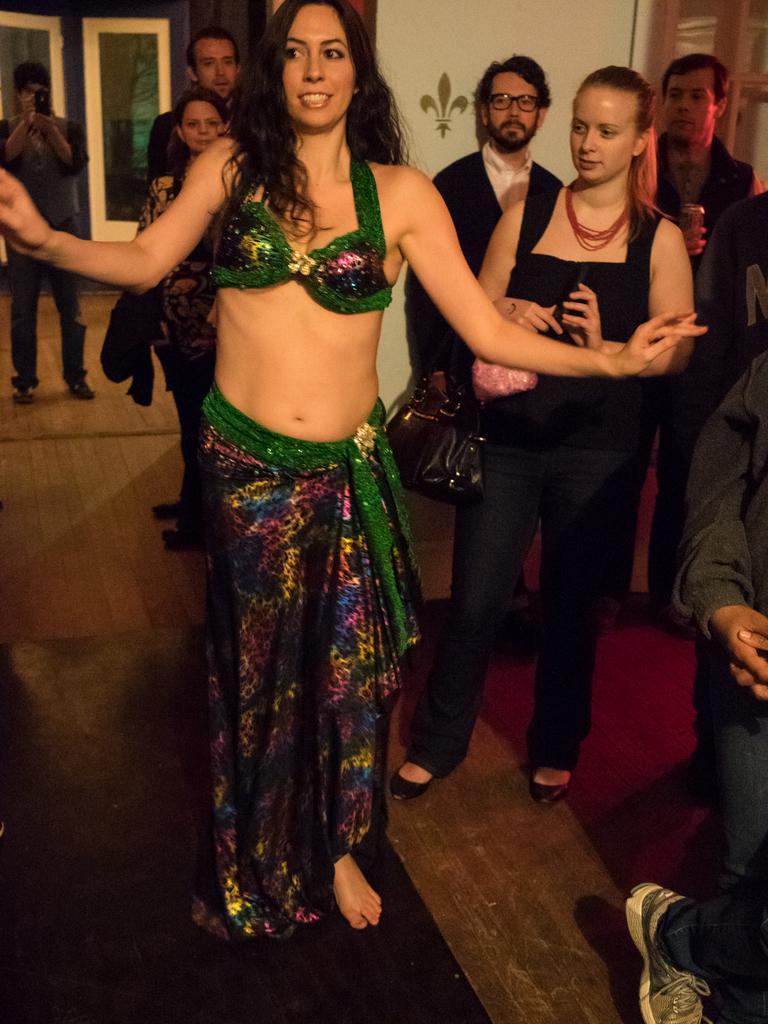Please provide a concise description of this image. In this image there are people standing on the floor. In the center there is a woman dancing. To the left there is a man holding a camera in his hand. Behind them there is a wall. There are glass doors to the wall. 